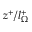<formula> <loc_0><loc_0><loc_500><loc_500>z ^ { + } / l _ { \Omega } ^ { + }</formula> 